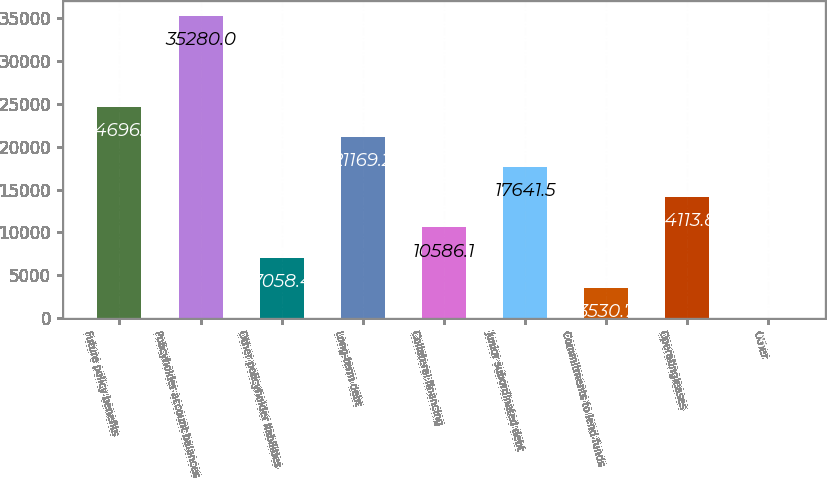Convert chart. <chart><loc_0><loc_0><loc_500><loc_500><bar_chart><fcel>Future policy benefits<fcel>Policyholder account balances<fcel>Other policyholder liabilities<fcel>Long-term debt<fcel>Collateral financing<fcel>Junior subordinated debt<fcel>Commitments to lend funds<fcel>Operatingleases<fcel>Other<nl><fcel>24696.9<fcel>35280<fcel>7058.4<fcel>21169.2<fcel>10586.1<fcel>17641.5<fcel>3530.7<fcel>14113.8<fcel>3<nl></chart> 